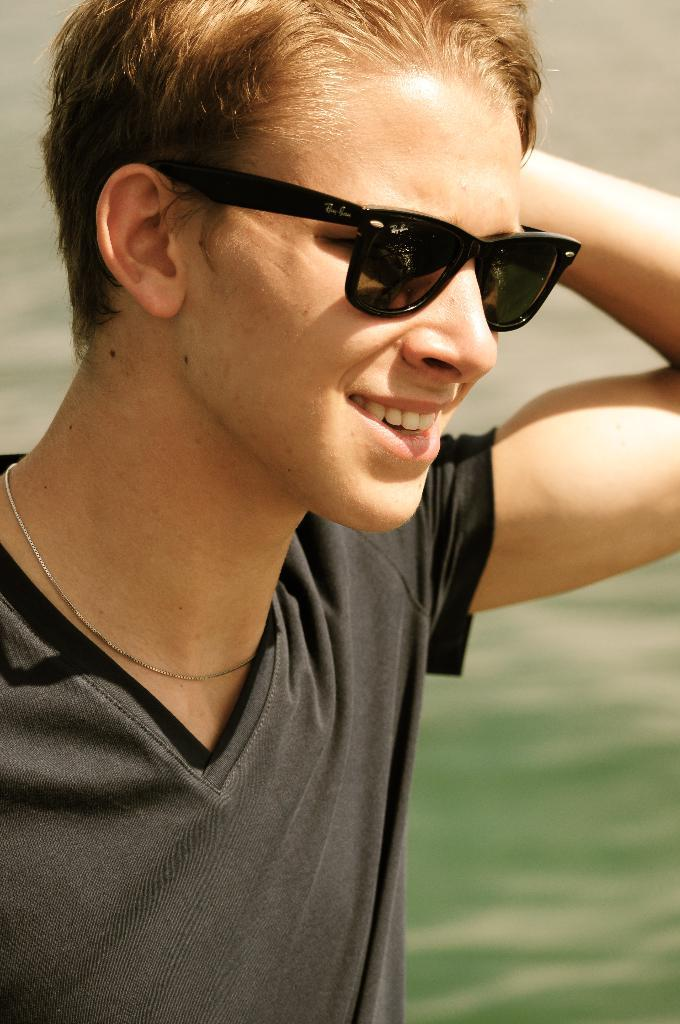What is the main subject of the image? There is a person in the image. What is the person wearing in the image? The person is wearing goggles. Can you describe the background of the image? The background of the image is blurry. What type of wire is the person holding in the image? There is no wire present in the image. Who is the creator of the goggles the person is wearing in the image? The image does not provide information about the creator of the goggles. What authority figure is depicted in the image? There is no authority figure depicted in the image; it only features a person wearing goggles. 